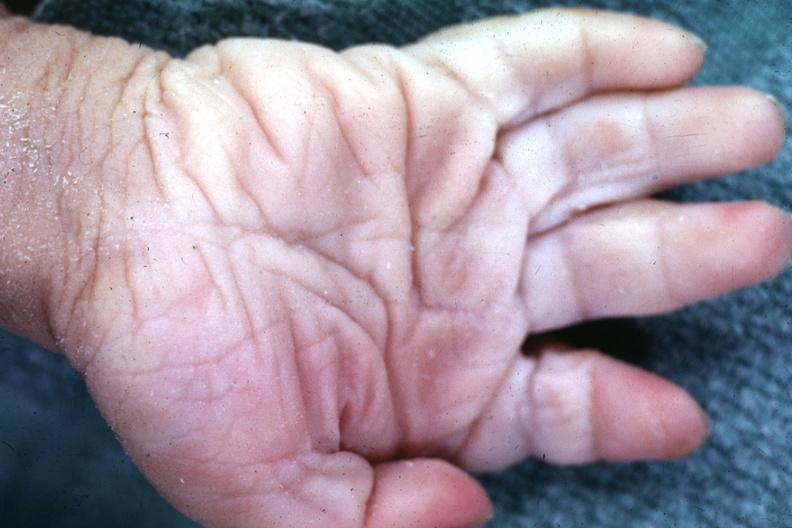what does this image show?
Answer the question using a single word or phrase. Simian crease 